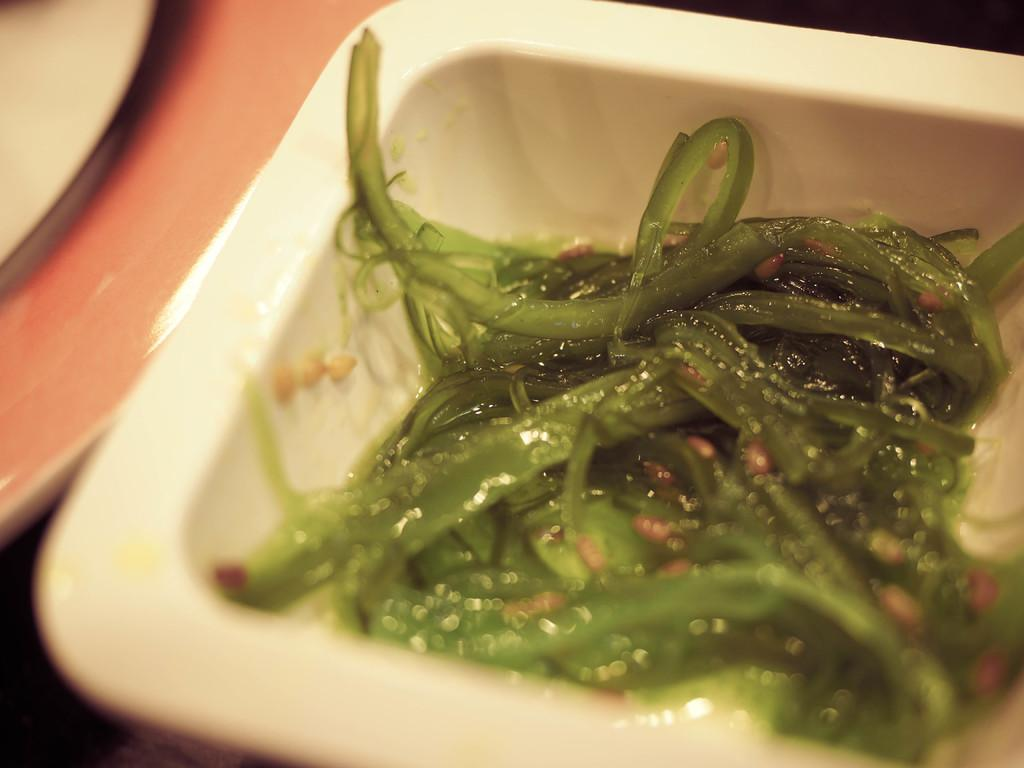What is the main subject in the image? There is a food item in a bowl in the image. Can you describe the food item in the bowl? Unfortunately, the specific food item cannot be identified from the provided facts. What else is visible in the image besides the food item in the bowl? There is an object beside the bowl in the image. Can you describe the object beside the bowl? Unfortunately, the specific object cannot be identified from the provided facts. What is the name of the person who is showing the zinc in the image? There is no person, zinc, or any indication of a demonstration in the image. 